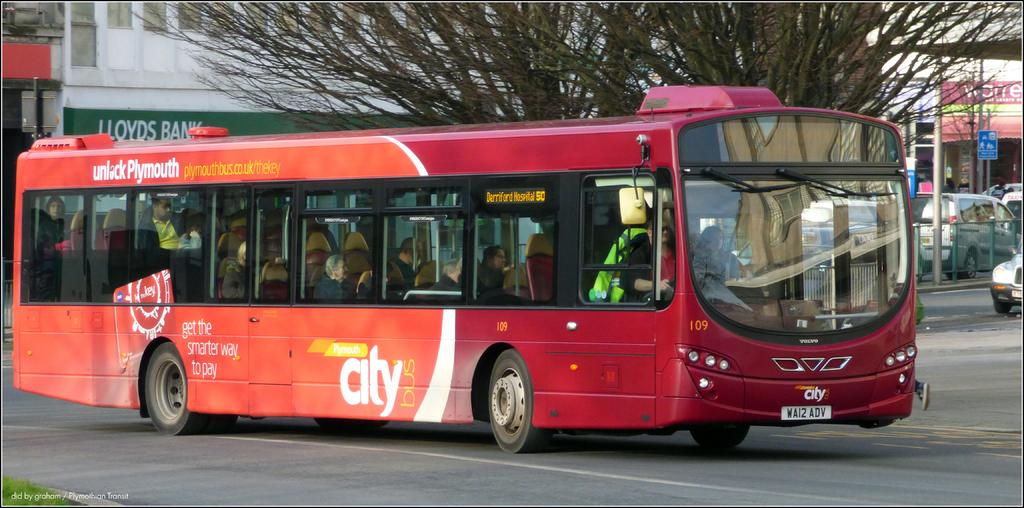<image>
Share a concise interpretation of the image provided. A red City Bus drives on the street. 